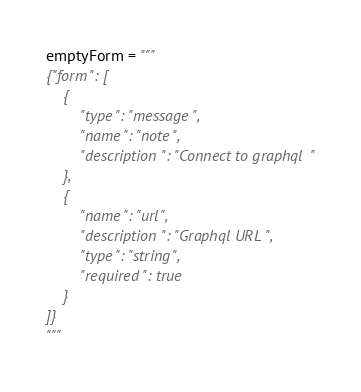Convert code to text. <code><loc_0><loc_0><loc_500><loc_500><_Python_>emptyForm = """
{"form": [
    {
        "type": "message",
        "name": "note",
        "description": "Connect to graphql"
    },
    {
        "name": "url",
        "description": "Graphql URL",
        "type": "string",
        "required": true
    }
]}
"""
</code> 